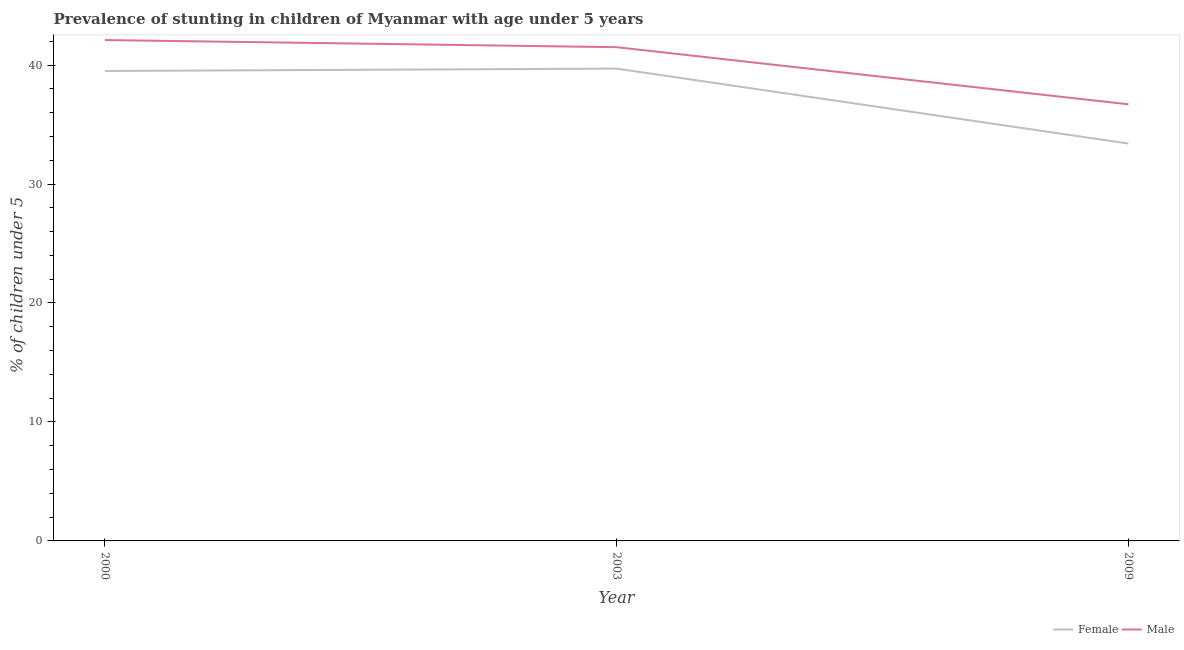Is the number of lines equal to the number of legend labels?
Your answer should be very brief. Yes. What is the percentage of stunted female children in 2003?
Make the answer very short. 39.7. Across all years, what is the maximum percentage of stunted male children?
Give a very brief answer. 42.1. Across all years, what is the minimum percentage of stunted female children?
Give a very brief answer. 33.4. In which year was the percentage of stunted male children maximum?
Ensure brevity in your answer.  2000. What is the total percentage of stunted male children in the graph?
Provide a short and direct response. 120.3. What is the difference between the percentage of stunted female children in 2000 and that in 2003?
Make the answer very short. -0.2. What is the difference between the percentage of stunted male children in 2009 and the percentage of stunted female children in 2000?
Provide a succinct answer. -2.8. What is the average percentage of stunted male children per year?
Your answer should be very brief. 40.1. In the year 2003, what is the difference between the percentage of stunted female children and percentage of stunted male children?
Provide a short and direct response. -1.8. What is the ratio of the percentage of stunted female children in 2003 to that in 2009?
Your answer should be very brief. 1.19. Is the difference between the percentage of stunted female children in 2000 and 2009 greater than the difference between the percentage of stunted male children in 2000 and 2009?
Give a very brief answer. Yes. What is the difference between the highest and the second highest percentage of stunted female children?
Provide a short and direct response. 0.2. What is the difference between the highest and the lowest percentage of stunted male children?
Keep it short and to the point. 5.4. Is the percentage of stunted male children strictly greater than the percentage of stunted female children over the years?
Offer a terse response. Yes. Is the percentage of stunted male children strictly less than the percentage of stunted female children over the years?
Ensure brevity in your answer.  No. Are the values on the major ticks of Y-axis written in scientific E-notation?
Provide a succinct answer. No. Does the graph contain any zero values?
Ensure brevity in your answer.  No. Where does the legend appear in the graph?
Your response must be concise. Bottom right. What is the title of the graph?
Provide a succinct answer. Prevalence of stunting in children of Myanmar with age under 5 years. What is the label or title of the X-axis?
Give a very brief answer. Year. What is the label or title of the Y-axis?
Ensure brevity in your answer.   % of children under 5. What is the  % of children under 5 of Female in 2000?
Offer a very short reply. 39.5. What is the  % of children under 5 in Male in 2000?
Keep it short and to the point. 42.1. What is the  % of children under 5 in Female in 2003?
Your response must be concise. 39.7. What is the  % of children under 5 of Male in 2003?
Ensure brevity in your answer.  41.5. What is the  % of children under 5 of Female in 2009?
Your response must be concise. 33.4. What is the  % of children under 5 of Male in 2009?
Offer a terse response. 36.7. Across all years, what is the maximum  % of children under 5 of Female?
Your response must be concise. 39.7. Across all years, what is the maximum  % of children under 5 in Male?
Offer a terse response. 42.1. Across all years, what is the minimum  % of children under 5 in Female?
Provide a short and direct response. 33.4. Across all years, what is the minimum  % of children under 5 in Male?
Offer a terse response. 36.7. What is the total  % of children under 5 of Female in the graph?
Your answer should be very brief. 112.6. What is the total  % of children under 5 of Male in the graph?
Your response must be concise. 120.3. What is the difference between the  % of children under 5 in Female in 2000 and that in 2003?
Your answer should be compact. -0.2. What is the difference between the  % of children under 5 of Male in 2000 and that in 2003?
Provide a short and direct response. 0.6. What is the difference between the  % of children under 5 of Female in 2003 and the  % of children under 5 of Male in 2009?
Ensure brevity in your answer.  3. What is the average  % of children under 5 of Female per year?
Offer a very short reply. 37.53. What is the average  % of children under 5 of Male per year?
Provide a succinct answer. 40.1. In the year 2003, what is the difference between the  % of children under 5 of Female and  % of children under 5 of Male?
Make the answer very short. -1.8. What is the ratio of the  % of children under 5 of Female in 2000 to that in 2003?
Offer a terse response. 0.99. What is the ratio of the  % of children under 5 of Male in 2000 to that in 2003?
Give a very brief answer. 1.01. What is the ratio of the  % of children under 5 of Female in 2000 to that in 2009?
Give a very brief answer. 1.18. What is the ratio of the  % of children under 5 in Male in 2000 to that in 2009?
Offer a terse response. 1.15. What is the ratio of the  % of children under 5 in Female in 2003 to that in 2009?
Offer a very short reply. 1.19. What is the ratio of the  % of children under 5 of Male in 2003 to that in 2009?
Your answer should be compact. 1.13. What is the difference between the highest and the second highest  % of children under 5 of Male?
Keep it short and to the point. 0.6. 